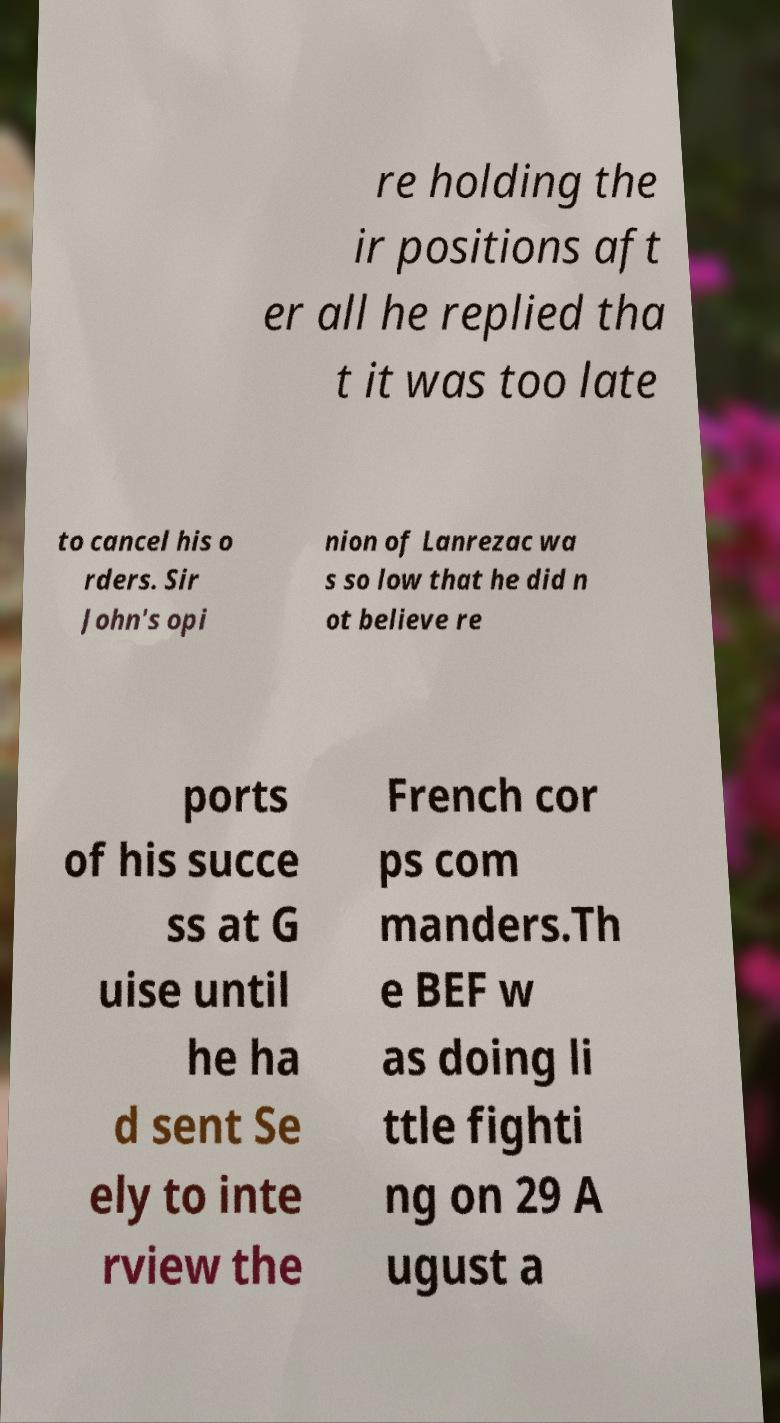What messages or text are displayed in this image? I need them in a readable, typed format. re holding the ir positions aft er all he replied tha t it was too late to cancel his o rders. Sir John's opi nion of Lanrezac wa s so low that he did n ot believe re ports of his succe ss at G uise until he ha d sent Se ely to inte rview the French cor ps com manders.Th e BEF w as doing li ttle fighti ng on 29 A ugust a 